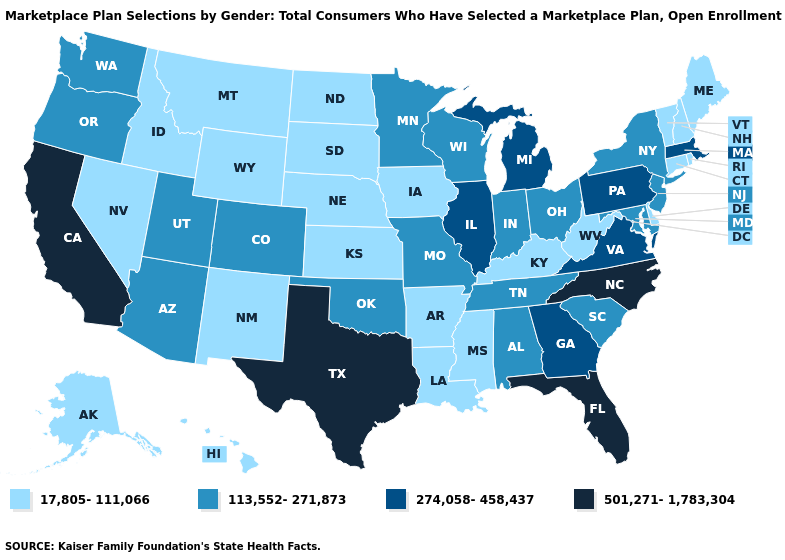Name the states that have a value in the range 113,552-271,873?
Short answer required. Alabama, Arizona, Colorado, Indiana, Maryland, Minnesota, Missouri, New Jersey, New York, Ohio, Oklahoma, Oregon, South Carolina, Tennessee, Utah, Washington, Wisconsin. Is the legend a continuous bar?
Answer briefly. No. What is the highest value in the USA?
Write a very short answer. 501,271-1,783,304. What is the value of New Hampshire?
Quick response, please. 17,805-111,066. What is the highest value in states that border Missouri?
Write a very short answer. 274,058-458,437. What is the highest value in the USA?
Be succinct. 501,271-1,783,304. What is the highest value in the USA?
Short answer required. 501,271-1,783,304. Name the states that have a value in the range 501,271-1,783,304?
Be succinct. California, Florida, North Carolina, Texas. Does the first symbol in the legend represent the smallest category?
Keep it brief. Yes. What is the lowest value in the South?
Answer briefly. 17,805-111,066. What is the value of Ohio?
Short answer required. 113,552-271,873. Does Oregon have a lower value than Idaho?
Give a very brief answer. No. What is the lowest value in states that border Michigan?
Be succinct. 113,552-271,873. Which states have the highest value in the USA?
Concise answer only. California, Florida, North Carolina, Texas. What is the value of Arkansas?
Keep it brief. 17,805-111,066. 